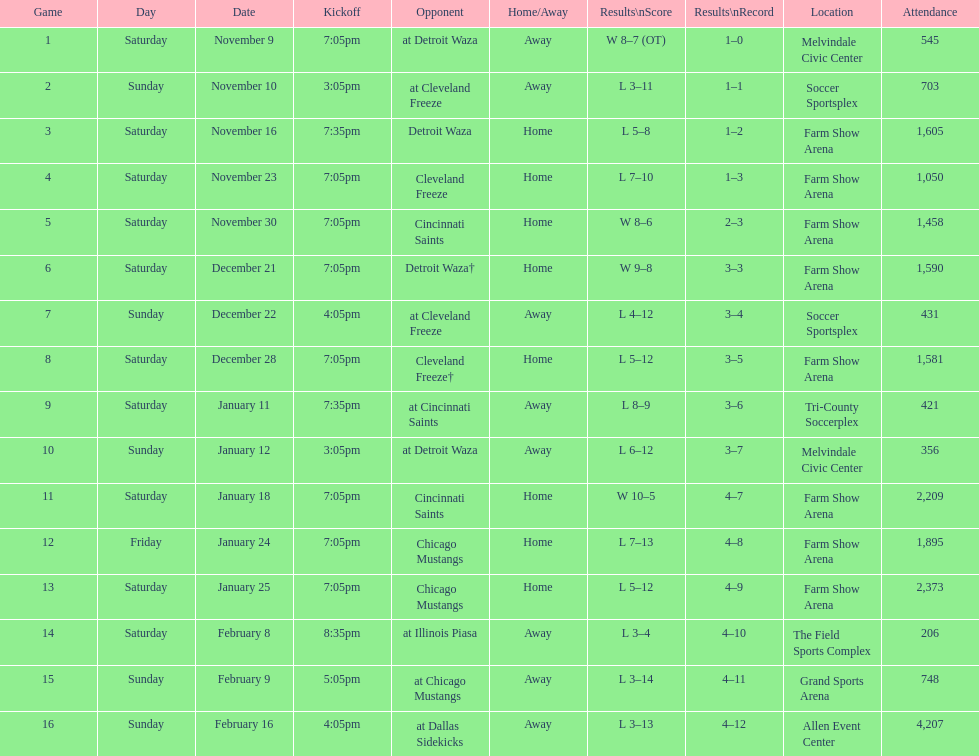How many games did the harrisburg heat lose to the cleveland freeze in total. 4. 